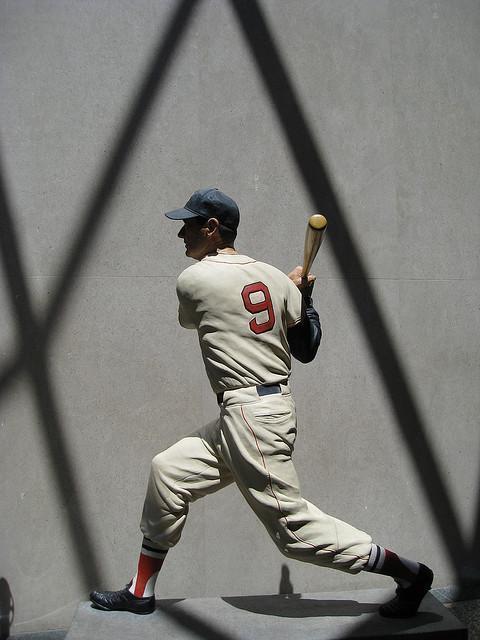How many people are riding?
Give a very brief answer. 0. 